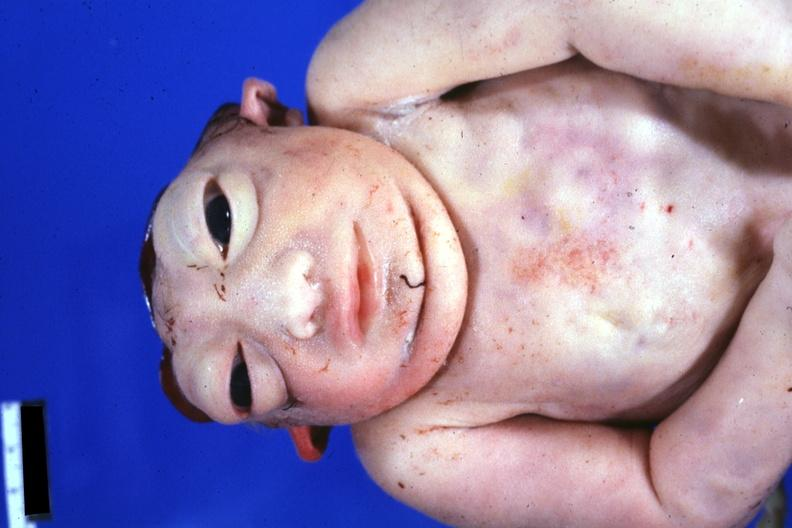does this image show view of face and chest anterior?
Answer the question using a single word or phrase. Yes 